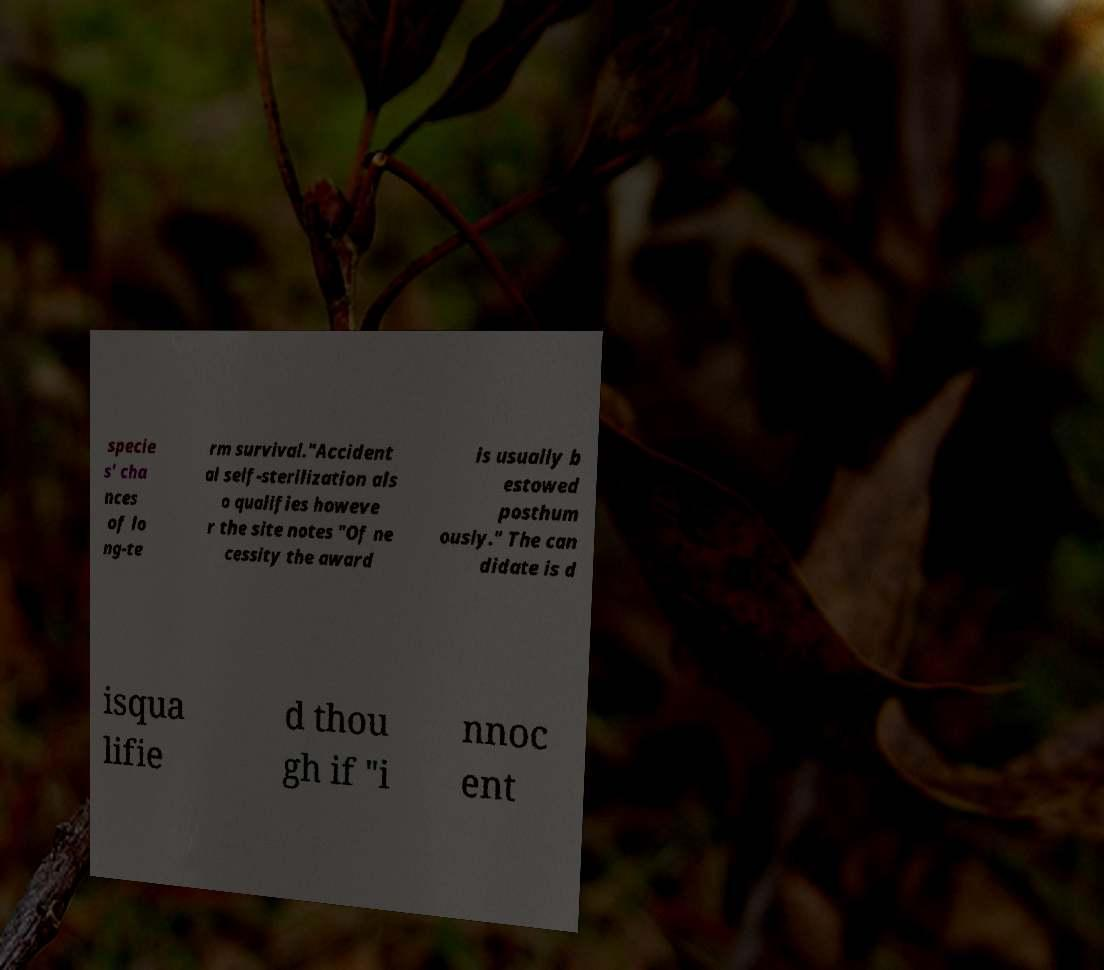Can you accurately transcribe the text from the provided image for me? specie s' cha nces of lo ng-te rm survival."Accident al self-sterilization als o qualifies howeve r the site notes "Of ne cessity the award is usually b estowed posthum ously." The can didate is d isqua lifie d thou gh if "i nnoc ent 